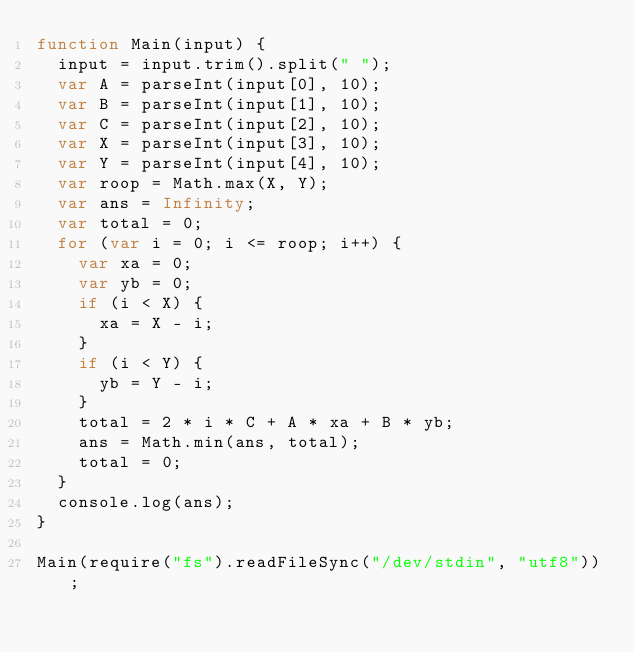Convert code to text. <code><loc_0><loc_0><loc_500><loc_500><_JavaScript_>function Main(input) {
  input = input.trim().split(" ");
  var A = parseInt(input[0], 10);
  var B = parseInt(input[1], 10);
  var C = parseInt(input[2], 10);
  var X = parseInt(input[3], 10);
  var Y = parseInt(input[4], 10);
  var roop = Math.max(X, Y);
  var ans = Infinity;
  var total = 0;
  for (var i = 0; i <= roop; i++) {
    var xa = 0;
    var yb = 0;
    if (i < X) {
      xa = X - i;
    }
    if (i < Y) {
      yb = Y - i;
    }
    total = 2 * i * C + A * xa + B * yb;
    ans = Math.min(ans, total);
    total = 0;
  }
  console.log(ans);
}

Main(require("fs").readFileSync("/dev/stdin", "utf8"));
</code> 